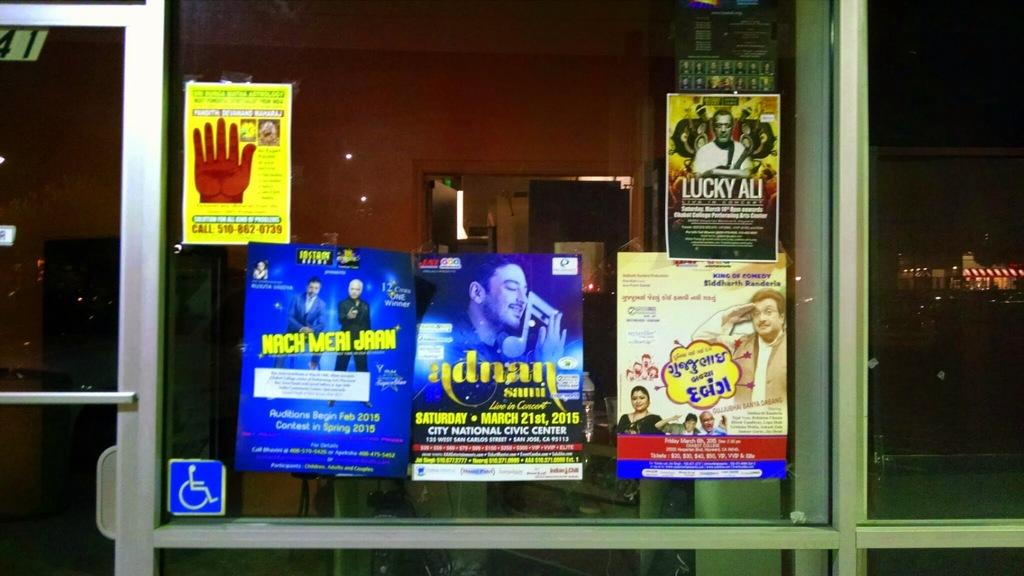<image>
Present a compact description of the photo's key features. A store front has several musical posters including one for adnan. 